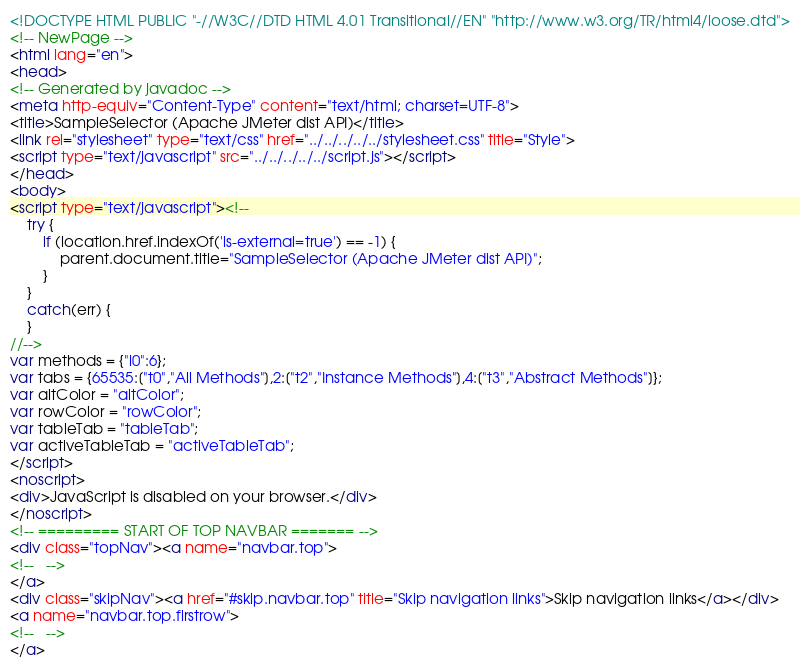Convert code to text. <code><loc_0><loc_0><loc_500><loc_500><_HTML_><!DOCTYPE HTML PUBLIC "-//W3C//DTD HTML 4.01 Transitional//EN" "http://www.w3.org/TR/html4/loose.dtd">
<!-- NewPage -->
<html lang="en">
<head>
<!-- Generated by javadoc -->
<meta http-equiv="Content-Type" content="text/html; charset=UTF-8">
<title>SampleSelector (Apache JMeter dist API)</title>
<link rel="stylesheet" type="text/css" href="../../../../../stylesheet.css" title="Style">
<script type="text/javascript" src="../../../../../script.js"></script>
</head>
<body>
<script type="text/javascript"><!--
    try {
        if (location.href.indexOf('is-external=true') == -1) {
            parent.document.title="SampleSelector (Apache JMeter dist API)";
        }
    }
    catch(err) {
    }
//-->
var methods = {"i0":6};
var tabs = {65535:["t0","All Methods"],2:["t2","Instance Methods"],4:["t3","Abstract Methods"]};
var altColor = "altColor";
var rowColor = "rowColor";
var tableTab = "tableTab";
var activeTableTab = "activeTableTab";
</script>
<noscript>
<div>JavaScript is disabled on your browser.</div>
</noscript>
<!-- ========= START OF TOP NAVBAR ======= -->
<div class="topNav"><a name="navbar.top">
<!--   -->
</a>
<div class="skipNav"><a href="#skip.navbar.top" title="Skip navigation links">Skip navigation links</a></div>
<a name="navbar.top.firstrow">
<!--   -->
</a></code> 